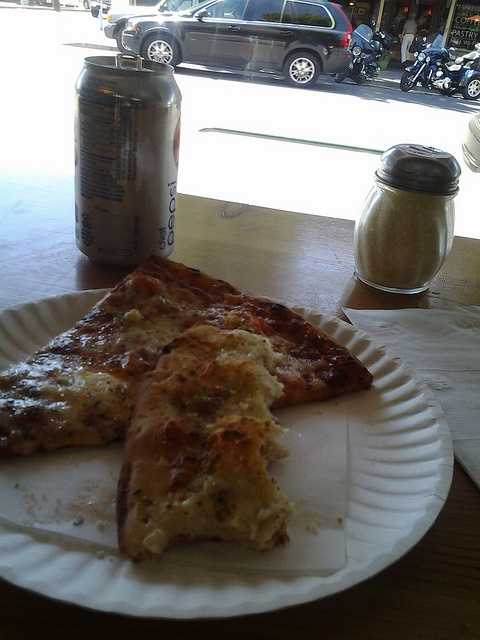Describe the objects in this image and their specific colors. I can see dining table in black, gray, white, maroon, and darkgray tones, pizza in gray, black, and maroon tones, pizza in gray, black, and maroon tones, car in gray, black, white, and darkgray tones, and bottle in gray and black tones in this image. 